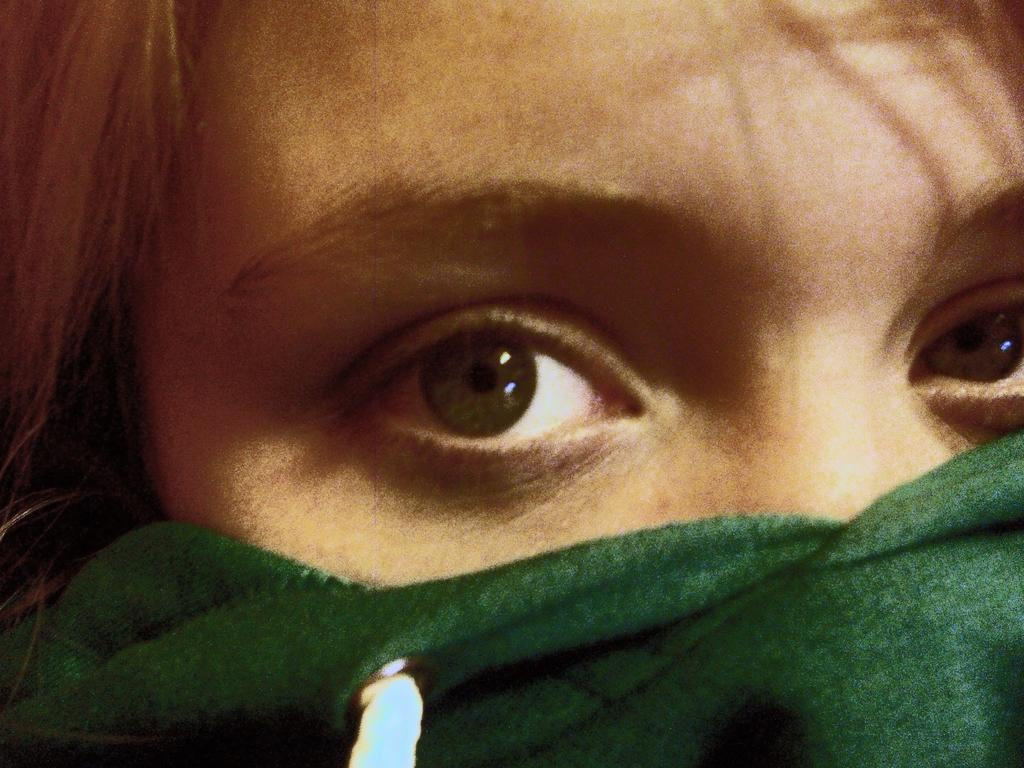What is the main subject of the image? There is a person in the image. What is the person wearing on their face? The person is wearing a mask on their face. Can you describe the lighting conditions in the image? The image may have been taken during the night. What type of building can be seen in the background of the image? There is no building visible in the image; it only features a person wearing a mask. How many yams are present in the image? There are no yams present in the image. 